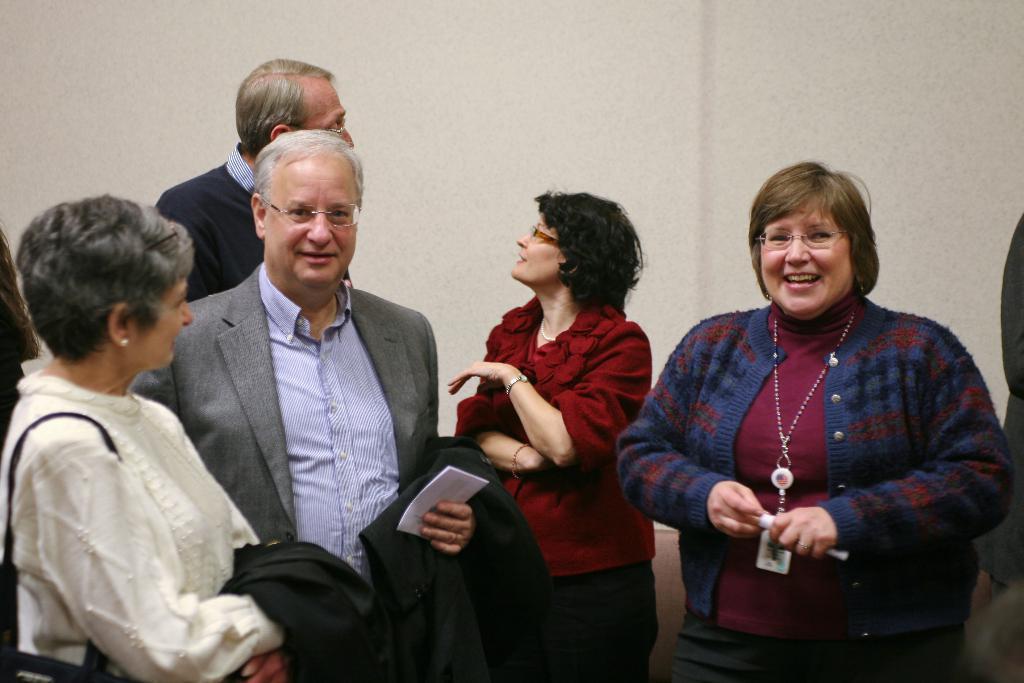Could you give a brief overview of what you see in this image? In this image there are group of people standing on the floor. In the middle there is a man who is holding the court and a paper. On the right side there is a woman who is laughing. In the background there is a wall. 